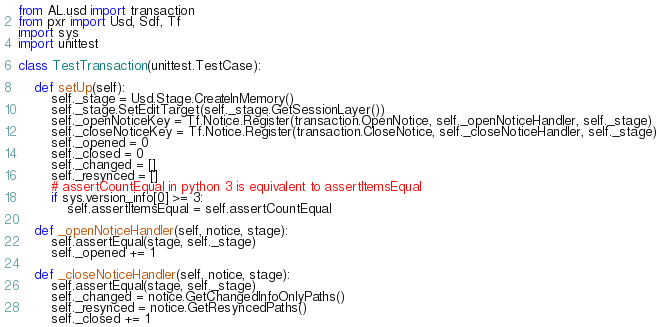Convert code to text. <code><loc_0><loc_0><loc_500><loc_500><_Python_>from AL.usd import transaction
from pxr import Usd, Sdf, Tf
import sys
import unittest

class TestTransaction(unittest.TestCase):

    def setUp(self):
        self._stage = Usd.Stage.CreateInMemory()
        self._stage.SetEditTarget(self._stage.GetSessionLayer())
        self._openNoticeKey = Tf.Notice.Register(transaction.OpenNotice, self._openNoticeHandler, self._stage)
        self._closeNoticeKey = Tf.Notice.Register(transaction.CloseNotice, self._closeNoticeHandler, self._stage)
        self._opened = 0
        self._closed = 0
        self._changed = []
        self._resynced = []
        # assertCountEqual in python 3 is equivalent to assertItemsEqual
        if sys.version_info[0] >= 3:
            self.assertItemsEqual = self.assertCountEqual

    def _openNoticeHandler(self, notice, stage):
        self.assertEqual(stage, self._stage)
        self._opened += 1

    def _closeNoticeHandler(self, notice, stage):
        self.assertEqual(stage, self._stage)
        self._changed = notice.GetChangedInfoOnlyPaths()
        self._resynced = notice.GetResyncedPaths()
        self._closed += 1
</code> 